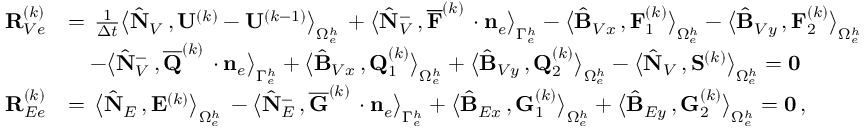Convert formula to latex. <formula><loc_0><loc_0><loc_500><loc_500>\begin{array} { r l } { { R } _ { V e } ^ { ( k ) } } & { = \, \frac { 1 } { \Delta t } \left \langle \hat { N } _ { V } \, , { U } ^ { ( k ) } - { U } ^ { ( k - 1 ) } \right \rangle _ { \Omega _ { e } ^ { h } } \, + \left \langle \hat { N } _ { V } ^ { - } \, , \overline { F } ^ { ( k ) } \, \cdot { n } _ { e } \right \rangle _ { \Gamma _ { e } ^ { h } } - \left \langle \hat { B } _ { V x } \, , { F } _ { 1 } ^ { ( k ) } \right \rangle _ { \Omega _ { e } ^ { h } } - \left \langle \hat { B } _ { V y } \, , { F } _ { 2 } ^ { ( k ) } \right \rangle _ { \Omega _ { e } ^ { h } } } \\ & { \quad - \left \langle \hat { N } _ { V } ^ { - } \, , \overline { Q } ^ { ( k ) } \, \cdot { n } _ { e } \right \rangle _ { \Gamma _ { e } ^ { h } } + \left \langle \hat { B } _ { V x } \, , { Q } _ { 1 } ^ { ( k ) } \right \rangle _ { \Omega _ { e } ^ { h } } + \left \langle \hat { B } _ { V y } \, , { Q } _ { 2 } ^ { ( k ) } \right \rangle _ { \Omega _ { e } ^ { h } } - \left \langle \hat { N } _ { V } \, , { S } ^ { ( k ) } \right \rangle _ { \Omega _ { e } ^ { h } } = { 0 } } \\ { { R } _ { E e } ^ { ( k ) } } & { = \, \left \langle \hat { N } _ { E } \, , { E } ^ { ( k ) } \right \rangle _ { \Omega _ { e } ^ { h } } \, - \left \langle \hat { N } _ { E } ^ { - } \, , \overline { G } ^ { ( k ) } \, \cdot { n } _ { e } \right \rangle _ { \Gamma _ { e } ^ { h } } + \left \langle \hat { B } _ { E x } \, , { G } _ { 1 } ^ { ( k ) } \right \rangle _ { \Omega _ { e } ^ { h } } + \left \langle \hat { B } _ { E y } \, , { G } _ { 2 } ^ { ( k ) } \right \rangle _ { \Omega _ { e } ^ { h } } = { 0 } \, , } \end{array}</formula> 